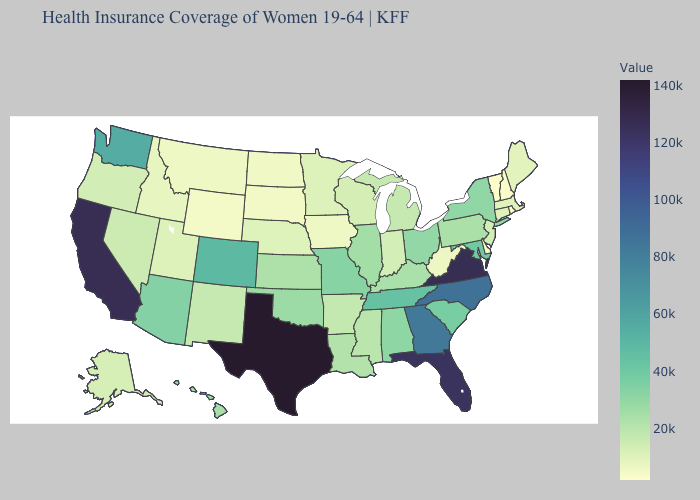Does Idaho have the lowest value in the West?
Short answer required. No. Which states have the highest value in the USA?
Be succinct. Texas. Among the states that border New York , does Connecticut have the lowest value?
Give a very brief answer. No. Does Delaware have a lower value than South Carolina?
Keep it brief. Yes. Does the map have missing data?
Answer briefly. No. Among the states that border Arkansas , which have the lowest value?
Short answer required. Mississippi. 